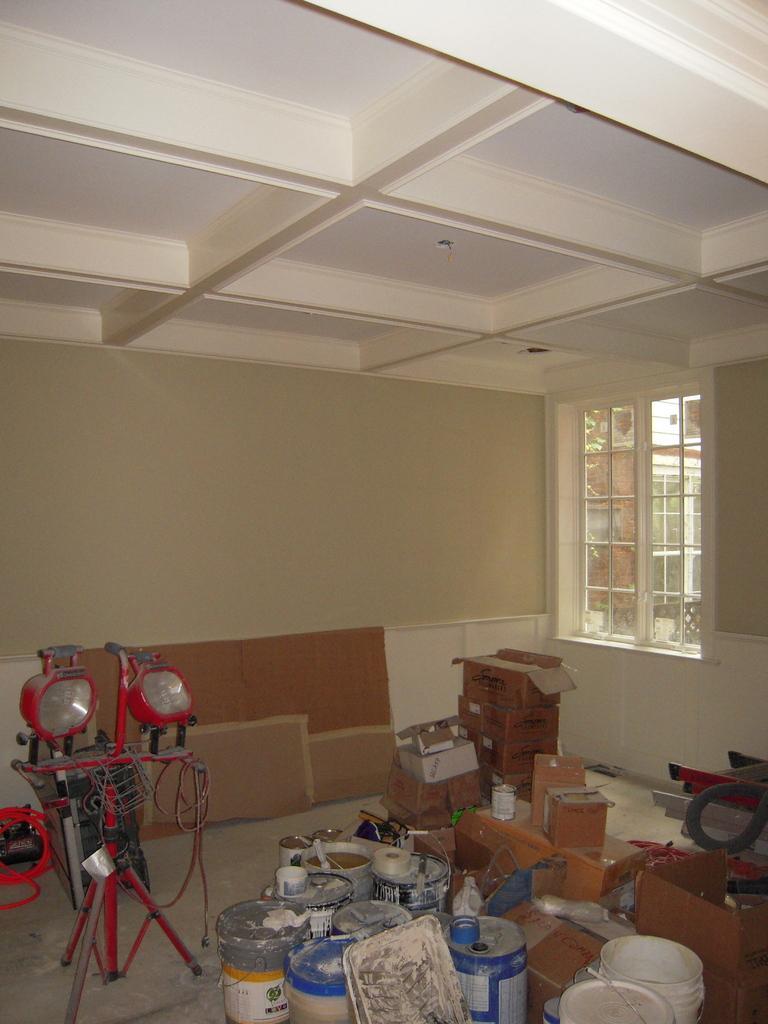Could you give a brief overview of what you see in this image? This picture is taken inside the room. In this image, on the right side, we can see some boxes. In the middle of the image, we can see some metal instrument. On the left side, we can also see an electronic instrument. In the background, we can see a wood wall. On the right side, we can also see a glass window, outside of the glass window, we can see a building. At the top, we can see a roof. 